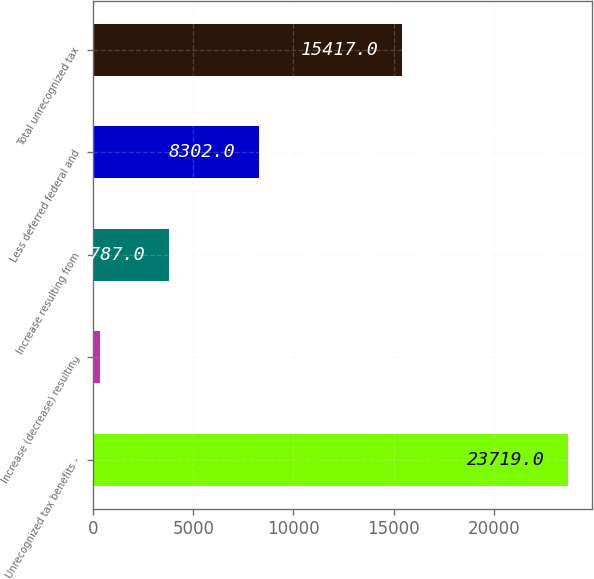Convert chart to OTSL. <chart><loc_0><loc_0><loc_500><loc_500><bar_chart><fcel>Unrecognized tax benefits -<fcel>Increase (decrease) resulting<fcel>Increase resulting from<fcel>Less deferred federal and<fcel>Total unrecognized tax<nl><fcel>23719<fcel>366<fcel>3787<fcel>8302<fcel>15417<nl></chart> 